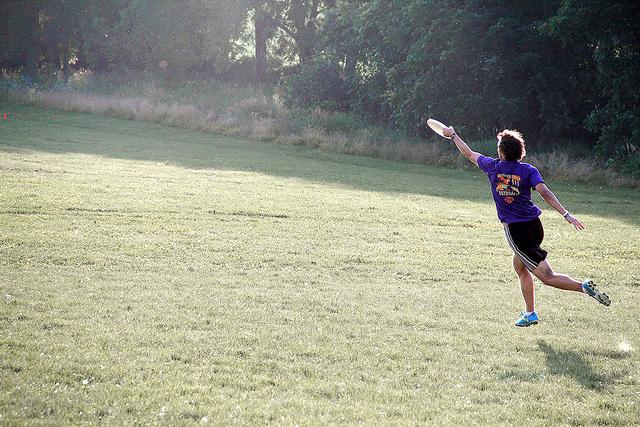What is the woman doing?
Concise answer only. Playing frisbee. Do you see any animals running around?
Concise answer only. No. What color is the ground?
Quick response, please. Green. Is this the beach?
Short answer required. No. Is this picture in color?
Concise answer only. Yes. Is this in a house?
Answer briefly. No. Is the man skiing?
Quick response, please. No. Is he dancing?
Concise answer only. No. 